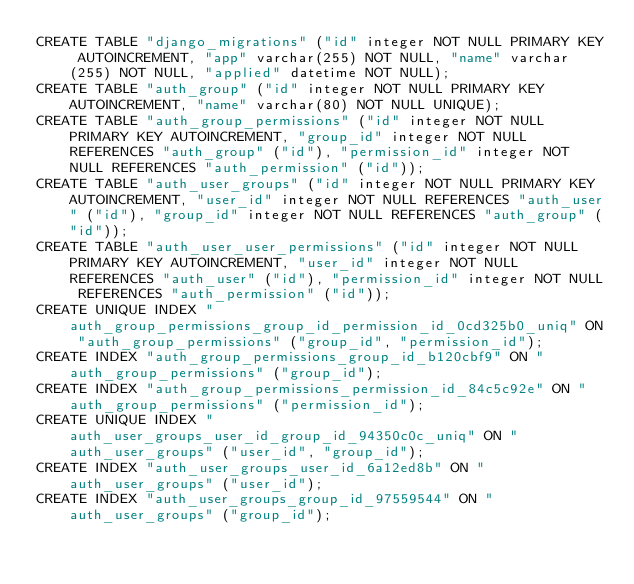<code> <loc_0><loc_0><loc_500><loc_500><_SQL_>CREATE TABLE "django_migrations" ("id" integer NOT NULL PRIMARY KEY AUTOINCREMENT, "app" varchar(255) NOT NULL, "name" varchar(255) NOT NULL, "applied" datetime NOT NULL);
CREATE TABLE "auth_group" ("id" integer NOT NULL PRIMARY KEY AUTOINCREMENT, "name" varchar(80) NOT NULL UNIQUE);
CREATE TABLE "auth_group_permissions" ("id" integer NOT NULL PRIMARY KEY AUTOINCREMENT, "group_id" integer NOT NULL REFERENCES "auth_group" ("id"), "permission_id" integer NOT NULL REFERENCES "auth_permission" ("id"));
CREATE TABLE "auth_user_groups" ("id" integer NOT NULL PRIMARY KEY AUTOINCREMENT, "user_id" integer NOT NULL REFERENCES "auth_user" ("id"), "group_id" integer NOT NULL REFERENCES "auth_group" ("id"));
CREATE TABLE "auth_user_user_permissions" ("id" integer NOT NULL PRIMARY KEY AUTOINCREMENT, "user_id" integer NOT NULL REFERENCES "auth_user" ("id"), "permission_id" integer NOT NULL REFERENCES "auth_permission" ("id"));
CREATE UNIQUE INDEX "auth_group_permissions_group_id_permission_id_0cd325b0_uniq" ON "auth_group_permissions" ("group_id", "permission_id");
CREATE INDEX "auth_group_permissions_group_id_b120cbf9" ON "auth_group_permissions" ("group_id");
CREATE INDEX "auth_group_permissions_permission_id_84c5c92e" ON "auth_group_permissions" ("permission_id");
CREATE UNIQUE INDEX "auth_user_groups_user_id_group_id_94350c0c_uniq" ON "auth_user_groups" ("user_id", "group_id");
CREATE INDEX "auth_user_groups_user_id_6a12ed8b" ON "auth_user_groups" ("user_id");
CREATE INDEX "auth_user_groups_group_id_97559544" ON "auth_user_groups" ("group_id");</code> 